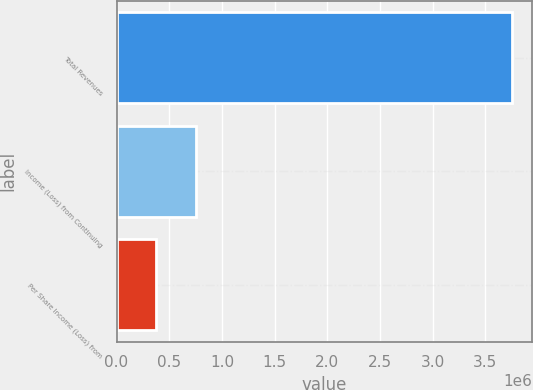Convert chart. <chart><loc_0><loc_0><loc_500><loc_500><bar_chart><fcel>Total Revenues<fcel>Income (Loss) from Continuing<fcel>Per Share Income (Loss) from<nl><fcel>3.7527e+06<fcel>750539<fcel>375270<nl></chart> 